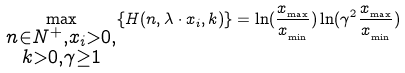Convert formula to latex. <formula><loc_0><loc_0><loc_500><loc_500>\max _ { \substack { n \in N ^ { + } , x _ { i } > 0 , \\ k > 0 , \gamma \geq 1 } } \{ H ( n , \lambda \cdot x _ { i } , k ) \} = \ln ( \frac { x _ { _ { \max } } } { x _ { _ { \min } } } ) \ln ( \gamma ^ { 2 } \frac { x _ { _ { \max } } } { x _ { _ { \min } } } )</formula> 